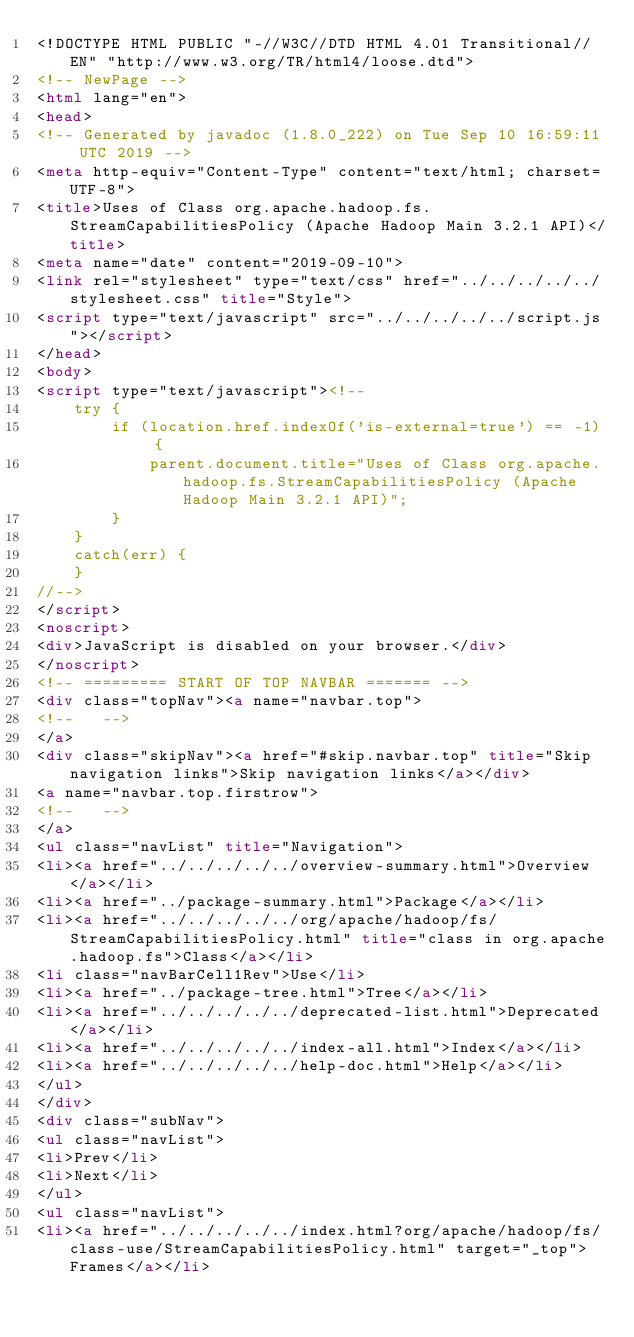<code> <loc_0><loc_0><loc_500><loc_500><_HTML_><!DOCTYPE HTML PUBLIC "-//W3C//DTD HTML 4.01 Transitional//EN" "http://www.w3.org/TR/html4/loose.dtd">
<!-- NewPage -->
<html lang="en">
<head>
<!-- Generated by javadoc (1.8.0_222) on Tue Sep 10 16:59:11 UTC 2019 -->
<meta http-equiv="Content-Type" content="text/html; charset=UTF-8">
<title>Uses of Class org.apache.hadoop.fs.StreamCapabilitiesPolicy (Apache Hadoop Main 3.2.1 API)</title>
<meta name="date" content="2019-09-10">
<link rel="stylesheet" type="text/css" href="../../../../../stylesheet.css" title="Style">
<script type="text/javascript" src="../../../../../script.js"></script>
</head>
<body>
<script type="text/javascript"><!--
    try {
        if (location.href.indexOf('is-external=true') == -1) {
            parent.document.title="Uses of Class org.apache.hadoop.fs.StreamCapabilitiesPolicy (Apache Hadoop Main 3.2.1 API)";
        }
    }
    catch(err) {
    }
//-->
</script>
<noscript>
<div>JavaScript is disabled on your browser.</div>
</noscript>
<!-- ========= START OF TOP NAVBAR ======= -->
<div class="topNav"><a name="navbar.top">
<!--   -->
</a>
<div class="skipNav"><a href="#skip.navbar.top" title="Skip navigation links">Skip navigation links</a></div>
<a name="navbar.top.firstrow">
<!--   -->
</a>
<ul class="navList" title="Navigation">
<li><a href="../../../../../overview-summary.html">Overview</a></li>
<li><a href="../package-summary.html">Package</a></li>
<li><a href="../../../../../org/apache/hadoop/fs/StreamCapabilitiesPolicy.html" title="class in org.apache.hadoop.fs">Class</a></li>
<li class="navBarCell1Rev">Use</li>
<li><a href="../package-tree.html">Tree</a></li>
<li><a href="../../../../../deprecated-list.html">Deprecated</a></li>
<li><a href="../../../../../index-all.html">Index</a></li>
<li><a href="../../../../../help-doc.html">Help</a></li>
</ul>
</div>
<div class="subNav">
<ul class="navList">
<li>Prev</li>
<li>Next</li>
</ul>
<ul class="navList">
<li><a href="../../../../../index.html?org/apache/hadoop/fs/class-use/StreamCapabilitiesPolicy.html" target="_top">Frames</a></li></code> 